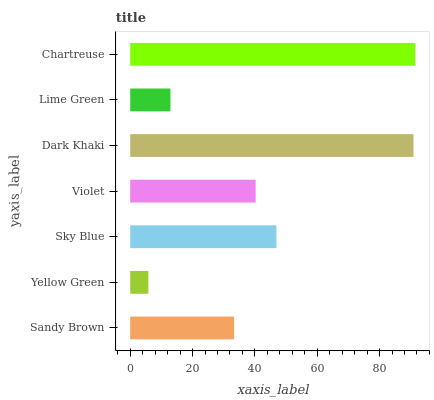Is Yellow Green the minimum?
Answer yes or no. Yes. Is Chartreuse the maximum?
Answer yes or no. Yes. Is Sky Blue the minimum?
Answer yes or no. No. Is Sky Blue the maximum?
Answer yes or no. No. Is Sky Blue greater than Yellow Green?
Answer yes or no. Yes. Is Yellow Green less than Sky Blue?
Answer yes or no. Yes. Is Yellow Green greater than Sky Blue?
Answer yes or no. No. Is Sky Blue less than Yellow Green?
Answer yes or no. No. Is Violet the high median?
Answer yes or no. Yes. Is Violet the low median?
Answer yes or no. Yes. Is Sandy Brown the high median?
Answer yes or no. No. Is Sandy Brown the low median?
Answer yes or no. No. 